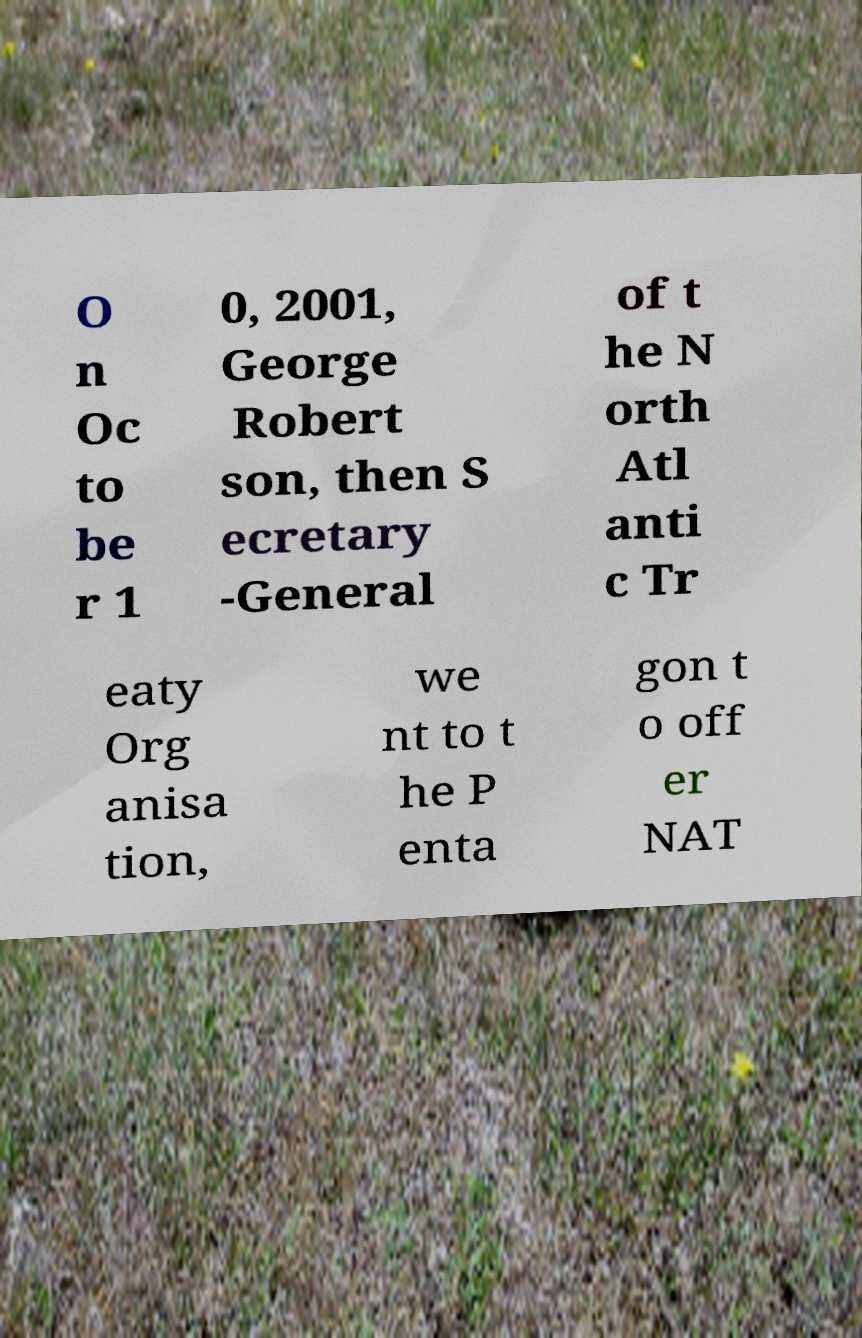Can you read and provide the text displayed in the image?This photo seems to have some interesting text. Can you extract and type it out for me? O n Oc to be r 1 0, 2001, George Robert son, then S ecretary -General of t he N orth Atl anti c Tr eaty Org anisa tion, we nt to t he P enta gon t o off er NAT 